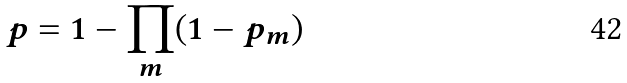Convert formula to latex. <formula><loc_0><loc_0><loc_500><loc_500>p = 1 - \prod _ { m } ( 1 - p _ { m } )</formula> 